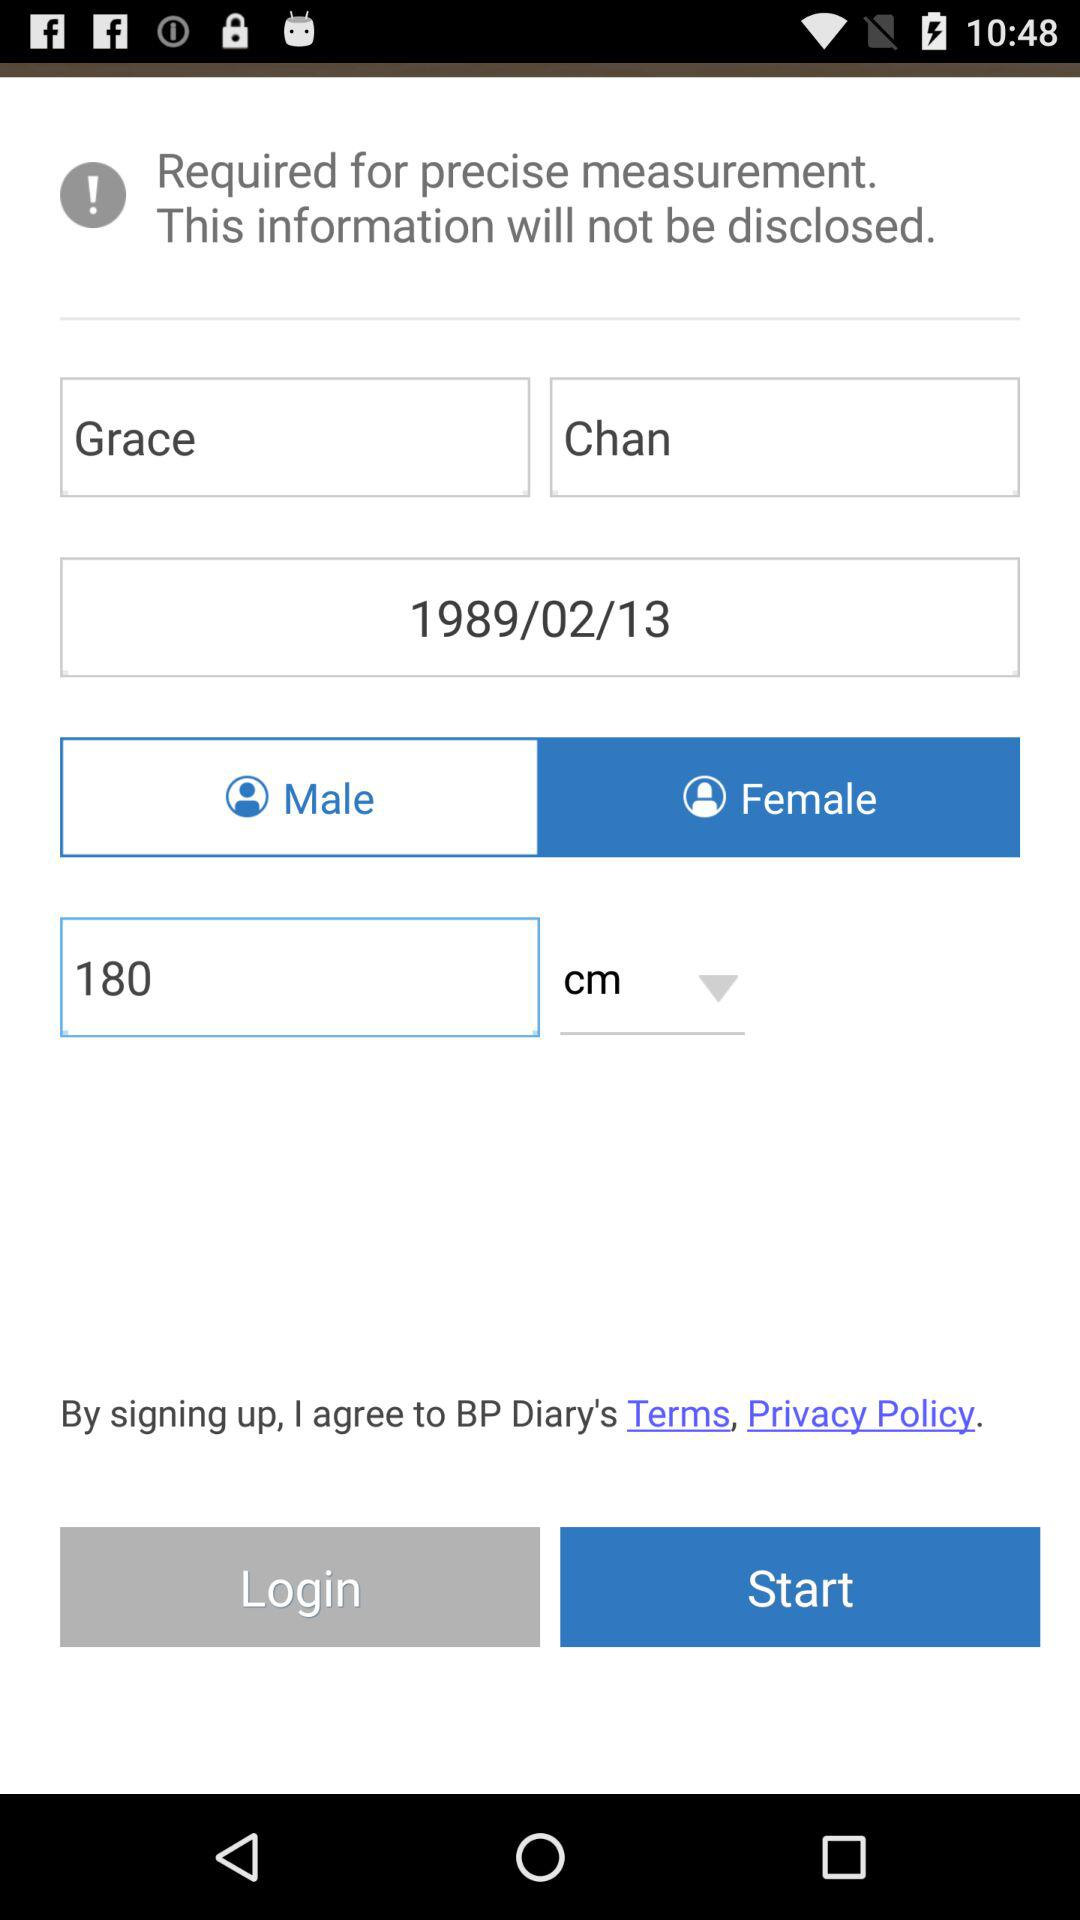What is the selected gender? The selected gender is female. 